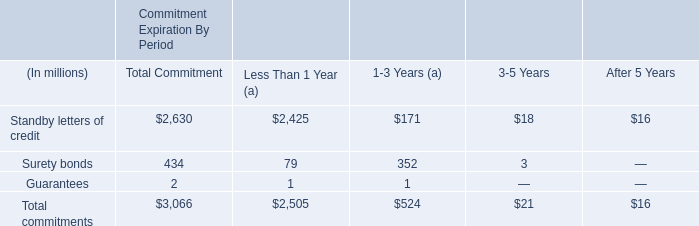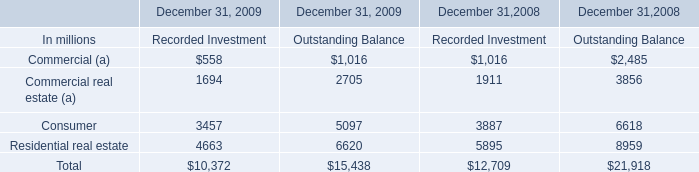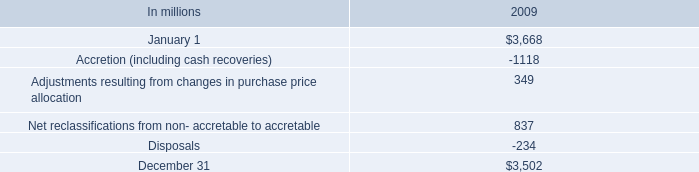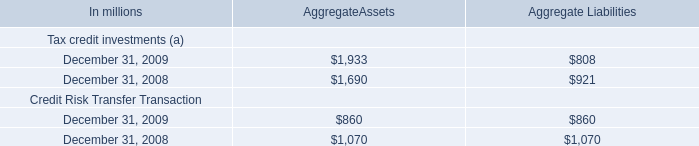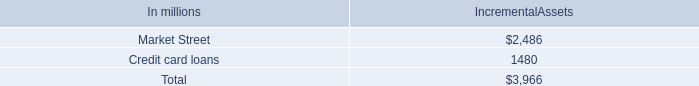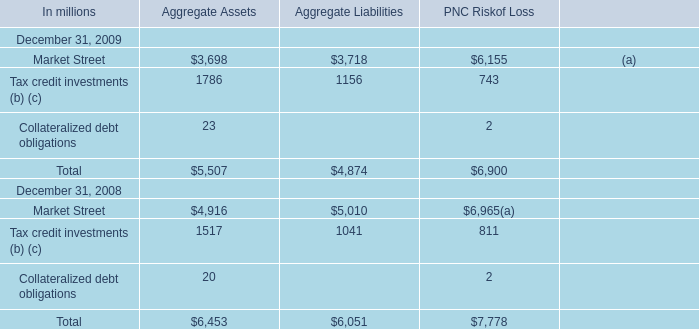The total amount of which section ranks first for AggregateAssets? (in million) 
Computations: (1933 + 1690)
Answer: 3623.0. 